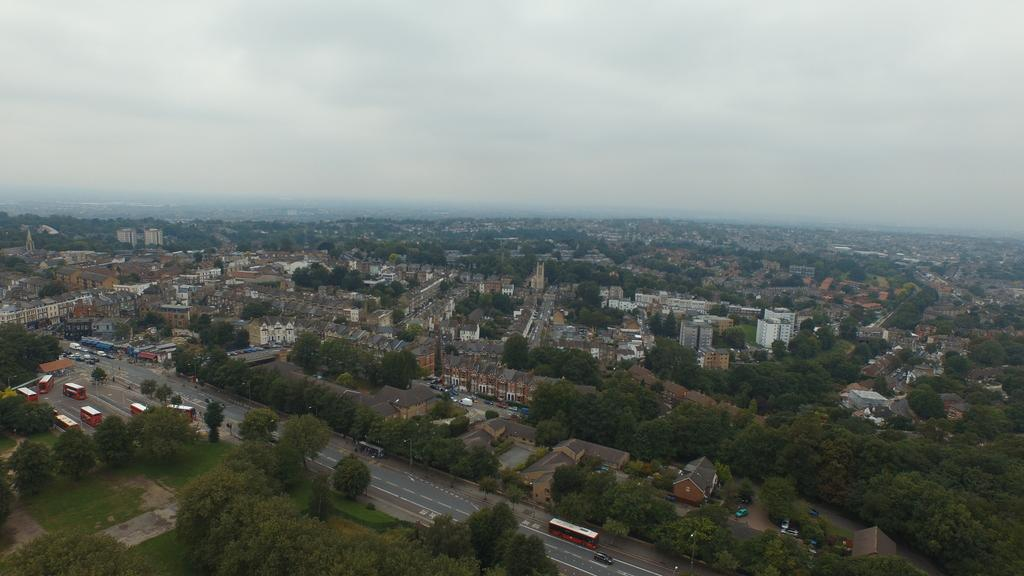What type of view is shown in the image? The image is an aerial view. What can be seen moving on the ground in the image? There are vehicles moving on the road in the image. What type of natural elements are visible in the image? There are trees visible in the image. What type of man-made structures can be seen in the image? There are buildings in the image. What is the condition of the sky in the image? The sky is cloudy at the top of the image. What type of square is being used for the feast in the image? There is no square or feast present in the image; it is an aerial view of a road, trees, buildings, and a cloudy sky. What record is being set by the vehicles in the image? There is no record being set by the vehicles in the image; they are simply moving on the road. 